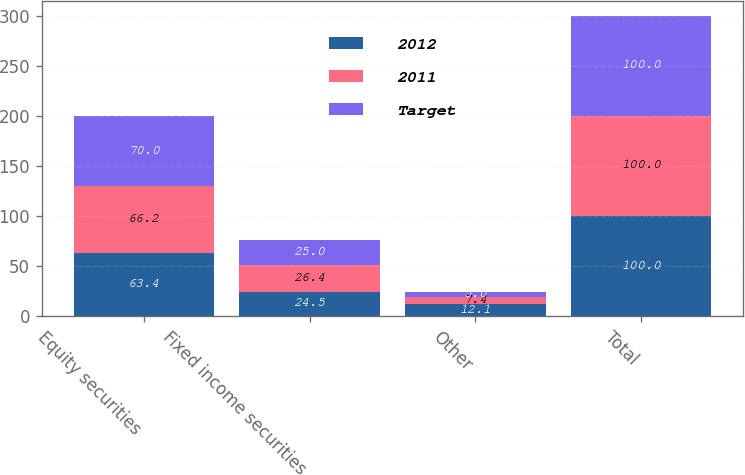Convert chart to OTSL. <chart><loc_0><loc_0><loc_500><loc_500><stacked_bar_chart><ecel><fcel>Equity securities<fcel>Fixed income securities<fcel>Other<fcel>Total<nl><fcel>2012<fcel>63.4<fcel>24.5<fcel>12.1<fcel>100<nl><fcel>2011<fcel>66.2<fcel>26.4<fcel>7.4<fcel>100<nl><fcel>Target<fcel>70<fcel>25<fcel>5<fcel>100<nl></chart> 